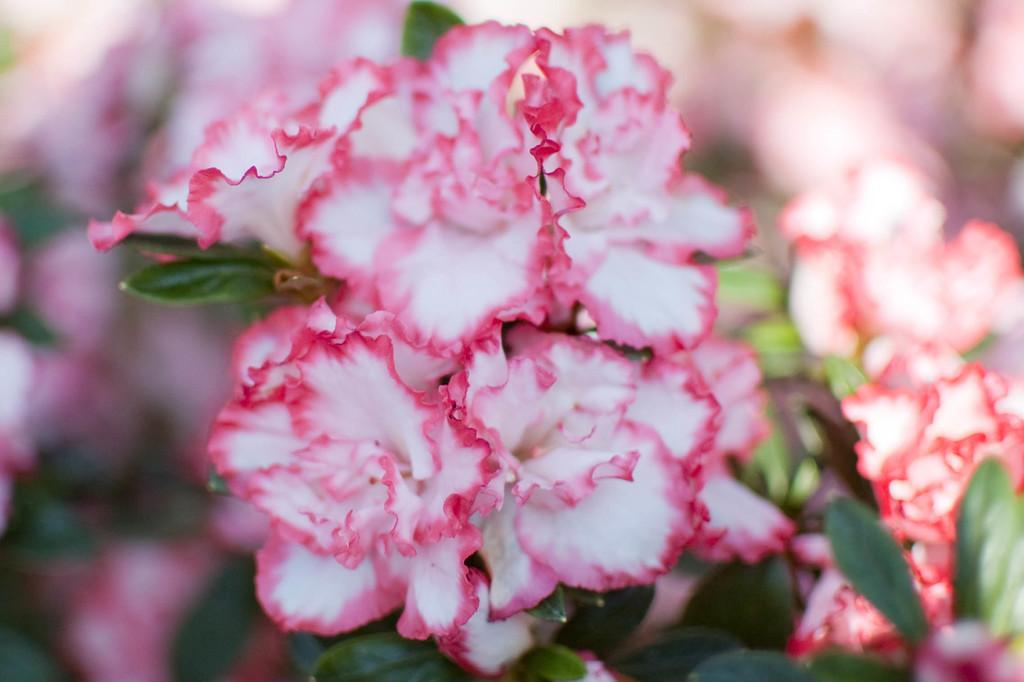What type of plant life is visible in the image? There are flowers and leaves in the image. Can you describe the background of the image? The background of the image is blurred. What type of vein is visible in the image? There are no veins present in the image; it features flowers and leaves. How many men can be seen in the image? There are no men present in the image. 